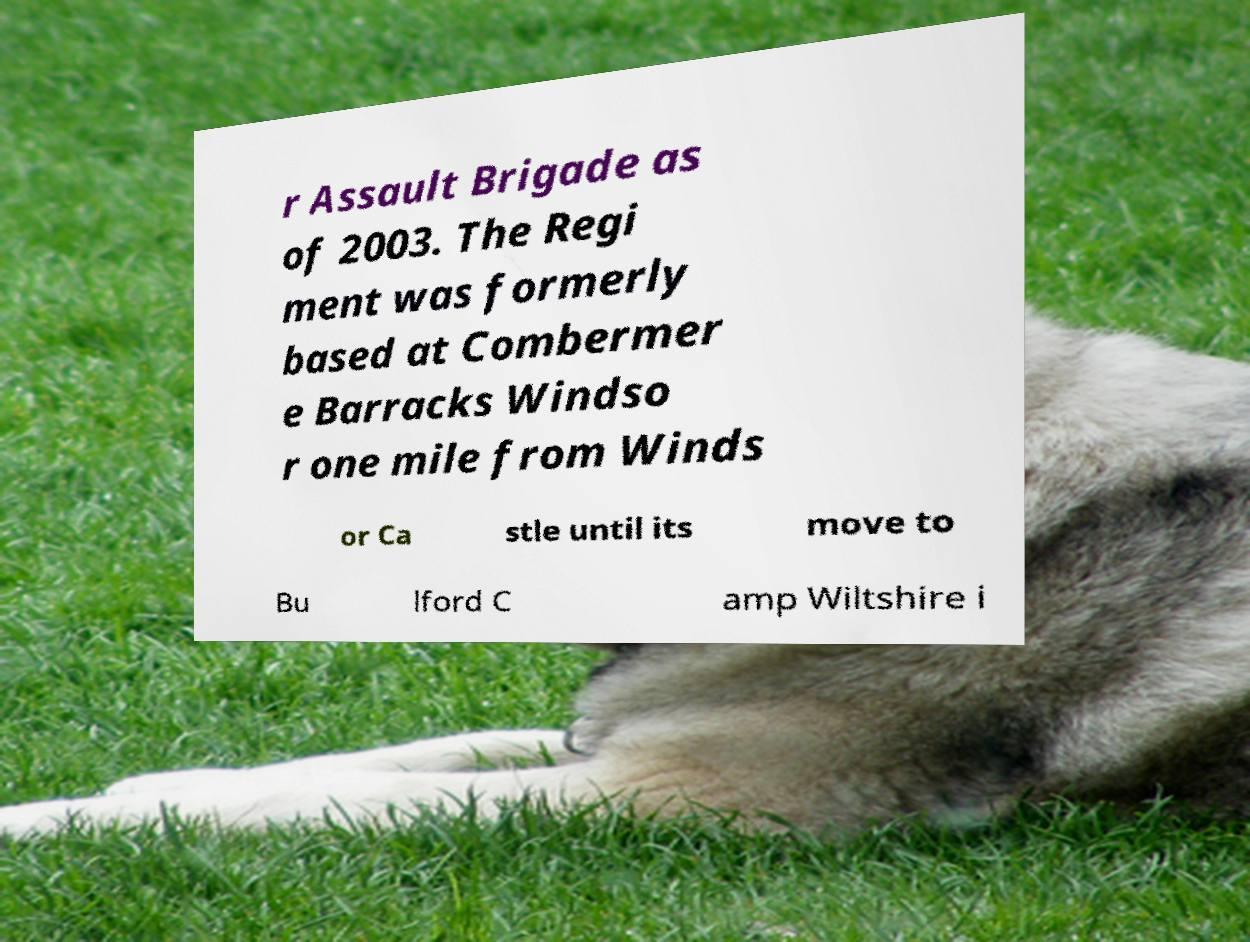Can you accurately transcribe the text from the provided image for me? r Assault Brigade as of 2003. The Regi ment was formerly based at Combermer e Barracks Windso r one mile from Winds or Ca stle until its move to Bu lford C amp Wiltshire i 